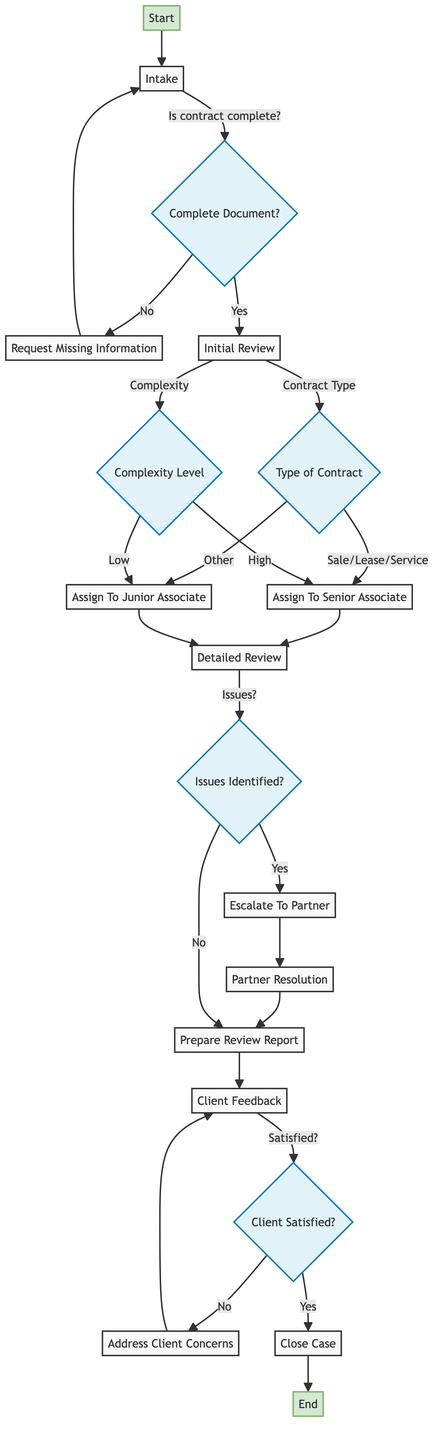What is the first step in the Contract Review Workflow? The first step in the Contract Review Workflow is labeled as "Start", which indicates the initiation of the review process. Therefore, the next action is to proceed to "Intake."
Answer: Start How many nodes are there in the Contract Review Workflow diagram? To determine the number of nodes, we can count each distinct step or decision point in the workflow from "Start" to "End." This results in a total of 14 nodes.
Answer: 14 What happens if the contract document is incomplete? According to the diagram, if the contract document is deemed incomplete, the workflow directs you to "Request Missing Information," which is a subsequent step before proceeding back to "Intake."
Answer: Request Missing Information Who reviews the contract if it is identified as complex? If the contract is identified as complex during the "Initial Review," the workflow directs the assignment to a "Senior Associate" for detailed review.
Answer: Senior Associate What is the outcome if there are issues identified during the Detailed Review? If issues are identified during the "Detailed Review," the workflow specifies that the issues must be escalated to a "Partner" for further resolution, leading to the "Partner Resolution" step.
Answer: Escalate To Partner What do you do after preparing the review report? After preparing the review report, the next step according to the workflow is to gather "Client Feedback" to ascertain the client’s satisfaction with the report.
Answer: Client Feedback What happens if the client is not satisfied with the review report? If the client is not satisfied, the flow indicates that the next action is to "Address Client Concerns," which may involve revising the report based on client feedback.
Answer: Address Client Concerns How many decisions are present in the diagram? The diagram contains multiple decision points, including questions regarding completeness, type of contract, complexity, issues identified, and client satisfaction. In total, there are 5 distinct decision points.
Answer: 5 What is the final step in the Contract Review Workflow? The final step in the Contract Review Workflow is labeled as "End," which indicates the conclusion of the entire process after the case has been closed.
Answer: End 